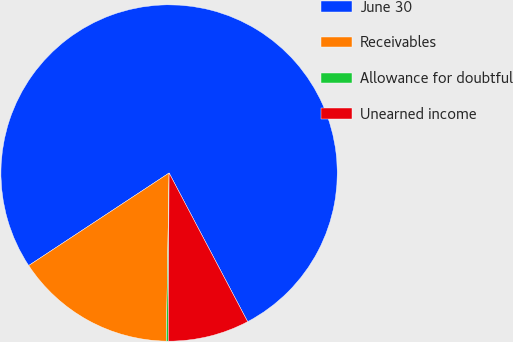Convert chart to OTSL. <chart><loc_0><loc_0><loc_500><loc_500><pie_chart><fcel>June 30<fcel>Receivables<fcel>Allowance for doubtful<fcel>Unearned income<nl><fcel>76.54%<fcel>15.46%<fcel>0.18%<fcel>7.82%<nl></chart> 